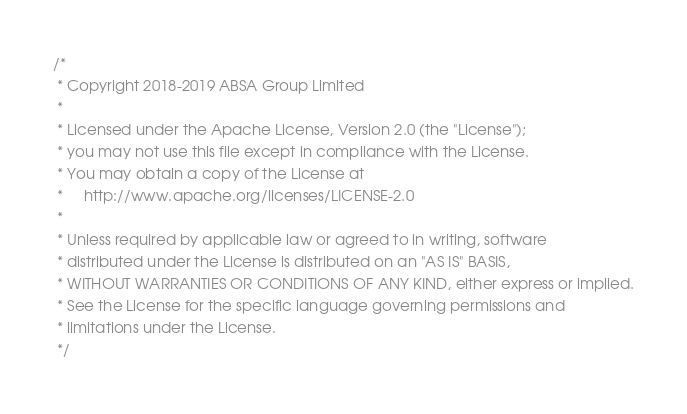<code> <loc_0><loc_0><loc_500><loc_500><_Scala_>/*
 * Copyright 2018-2019 ABSA Group Limited
 *
 * Licensed under the Apache License, Version 2.0 (the "License");
 * you may not use this file except in compliance with the License.
 * You may obtain a copy of the License at
 *     http://www.apache.org/licenses/LICENSE-2.0
 *
 * Unless required by applicable law or agreed to in writing, software
 * distributed under the License is distributed on an "AS IS" BASIS,
 * WITHOUT WARRANTIES OR CONDITIONS OF ANY KIND, either express or implied.
 * See the License for the specific language governing permissions and
 * limitations under the License.
 */
</code> 